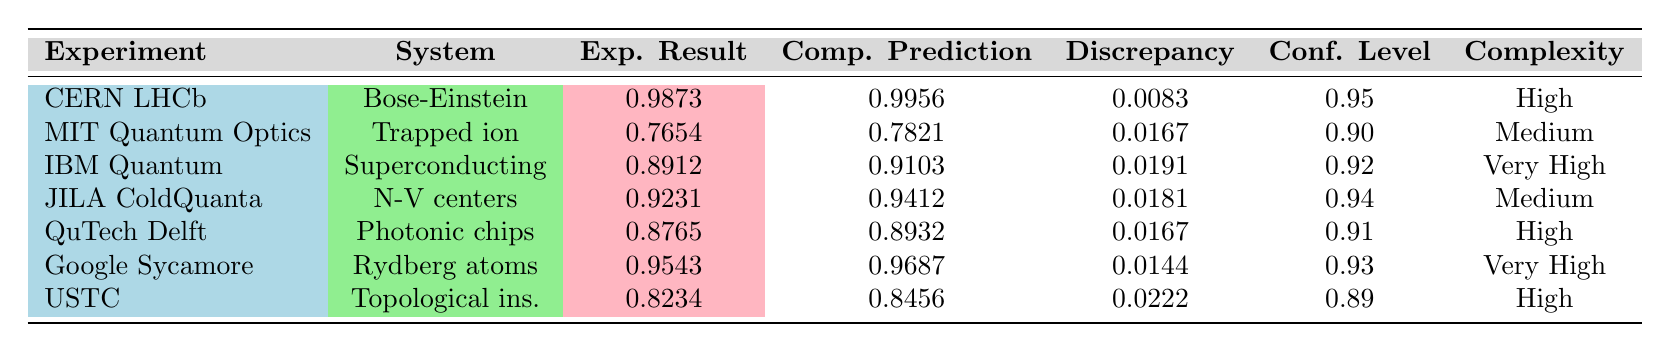What is the experimental result for the IBM Quantum experiment? Looking at the table, in the row for the IBM Quantum experiment, the column labeled "Exp. Result" shows the value 0.8912.
Answer: 0.8912 Which experiment had the highest discrepancy between experimental results and computational predictions? By comparing the "Discrepancy" values for all experiments in the table, the highest value is 0.0222, which corresponds to the USTC experiment.
Answer: USTC What is the confidence level associated with the QuTech Delft University experiment? In the row for QuTech Delft, the column labeled "Conf. Level" indicates a value of 0.91.
Answer: 0.91 How many of the systems listed have a "Very High" complexity? The table lists two systems with "Very High" complexity: Superconducting circuits (IBM Quantum) and Rydberg atom arrays (Google Sycamore). Thus, there are two instances.
Answer: 2 What is the average experimental result across all experiments? Summing all the experimental results (0.9873 + 0.7654 + 0.8912 + 0.9231 + 0.8765 + 0.9543 + 0.8234) gives 5.3973. Dividing by the number of experiments (7) results in an average of approximately 0.7710.
Answer: 0.7710 Did the Google Sycamore processor have a higher experimental result than the computational prediction? In the table, the experimental result for Google Sycamore is 0.9543, and the computational prediction is 0.9687. Since 0.9543 is less than 0.9687, the answer is no; it did not exceed the prediction.
Answer: No Which system has the highest experimental result, and what is that value? Reviewing the "Exp. Result" column, the highest value is 0.9873, associated with the Bose-Einstein condensates from the CERN LHCb collaboration.
Answer: Bose-Einstein condensates, 0.9873 What is the difference in confidence levels between the JILA ColdQuanta experiment and the USTC experiment? The confidence level for the JILA ColdQuanta experiment is 0.94, and for the USTC experiment, it is 0.89. The difference is calculated as 0.94 - 0.89 = 0.05.
Answer: 0.05 Which experiment has the lowest experimental result and what is its complexity? The lowest experimental result is 0.7654 from the MIT Quantum Optics experiment, and its complexity is listed as "Medium."
Answer: MIT Quantum Optics, Medium Is the discrepancy for the Rydberg atom arrays less than the average discrepancy across all experiments? The average discrepancy can be calculated as approximately 0.0168. The discrepancy for the Rydberg atom arrays is 0.0144, which is less than 0.0168. Therefore, the answer is yes.
Answer: Yes 